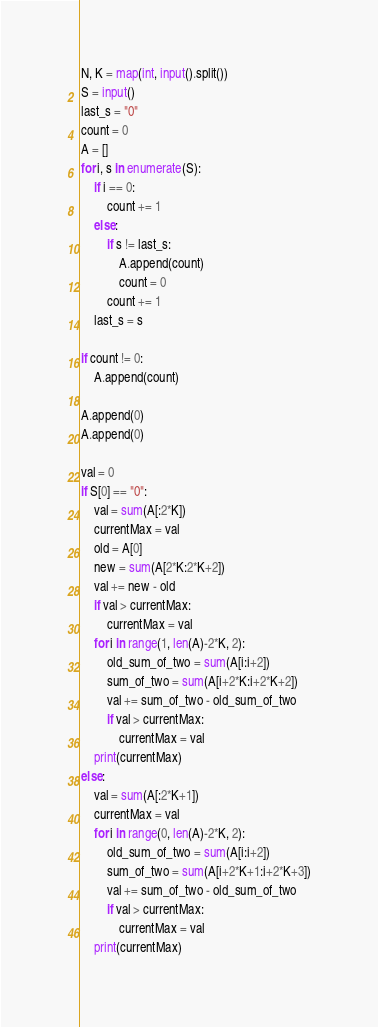<code> <loc_0><loc_0><loc_500><loc_500><_Python_>N, K = map(int, input().split())
S = input()
last_s = "0"
count = 0
A = []
for i, s in enumerate(S):
	if i == 0:
		count += 1
	else:
		if s != last_s:
			A.append(count)
			count = 0
		count += 1
	last_s = s

if count != 0:
	A.append(count)

A.append(0)
A.append(0)

val = 0
if S[0] == "0":
	val = sum(A[:2*K])
	currentMax = val
	old = A[0]
	new = sum(A[2*K:2*K+2])
	val += new - old
	if val > currentMax:
		currentMax = val
	for i in range(1, len(A)-2*K, 2):
		old_sum_of_two = sum(A[i:i+2])
		sum_of_two = sum(A[i+2*K:i+2*K+2])
		val += sum_of_two - old_sum_of_two
		if val > currentMax:
			currentMax = val
	print(currentMax)
else:
	val = sum(A[:2*K+1])
	currentMax = val
	for i in range(0, len(A)-2*K, 2):
		old_sum_of_two = sum(A[i:i+2])
		sum_of_two = sum(A[i+2*K+1:i+2*K+3])
		val += sum_of_two - old_sum_of_two
		if val > currentMax:
			currentMax = val
	print(currentMax)

</code> 